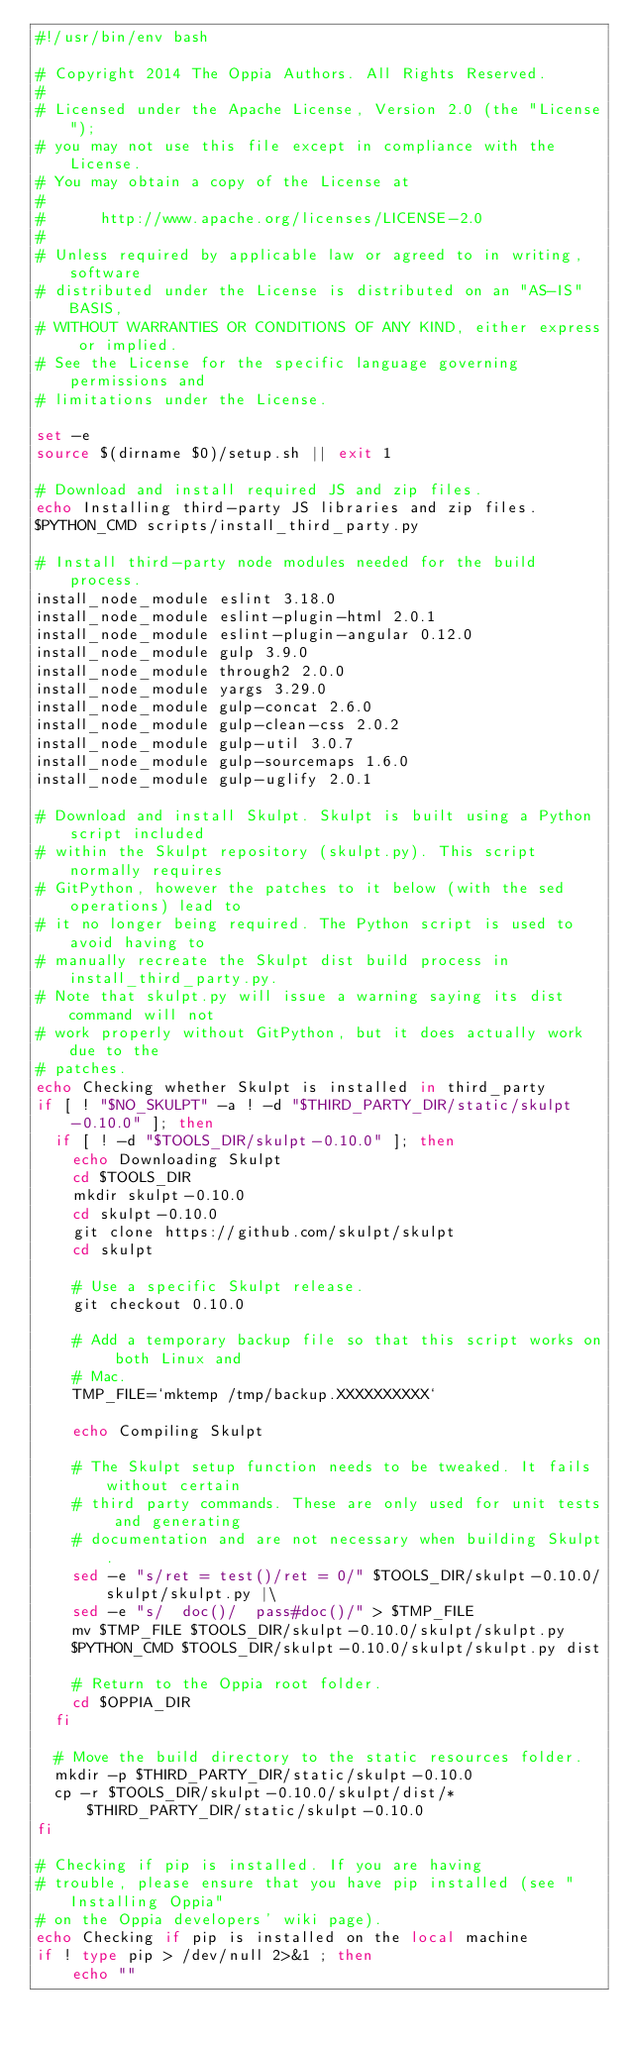<code> <loc_0><loc_0><loc_500><loc_500><_Bash_>#!/usr/bin/env bash

# Copyright 2014 The Oppia Authors. All Rights Reserved.
#
# Licensed under the Apache License, Version 2.0 (the "License");
# you may not use this file except in compliance with the License.
# You may obtain a copy of the License at
#
#      http://www.apache.org/licenses/LICENSE-2.0
#
# Unless required by applicable law or agreed to in writing, software
# distributed under the License is distributed on an "AS-IS" BASIS,
# WITHOUT WARRANTIES OR CONDITIONS OF ANY KIND, either express or implied.
# See the License for the specific language governing permissions and
# limitations under the License.

set -e
source $(dirname $0)/setup.sh || exit 1

# Download and install required JS and zip files.
echo Installing third-party JS libraries and zip files.
$PYTHON_CMD scripts/install_third_party.py

# Install third-party node modules needed for the build process.
install_node_module eslint 3.18.0
install_node_module eslint-plugin-html 2.0.1
install_node_module eslint-plugin-angular 0.12.0
install_node_module gulp 3.9.0
install_node_module through2 2.0.0
install_node_module yargs 3.29.0
install_node_module gulp-concat 2.6.0
install_node_module gulp-clean-css 2.0.2
install_node_module gulp-util 3.0.7
install_node_module gulp-sourcemaps 1.6.0
install_node_module gulp-uglify 2.0.1

# Download and install Skulpt. Skulpt is built using a Python script included
# within the Skulpt repository (skulpt.py). This script normally requires
# GitPython, however the patches to it below (with the sed operations) lead to
# it no longer being required. The Python script is used to avoid having to
# manually recreate the Skulpt dist build process in install_third_party.py.
# Note that skulpt.py will issue a warning saying its dist command will not
# work properly without GitPython, but it does actually work due to the
# patches.
echo Checking whether Skulpt is installed in third_party
if [ ! "$NO_SKULPT" -a ! -d "$THIRD_PARTY_DIR/static/skulpt-0.10.0" ]; then
  if [ ! -d "$TOOLS_DIR/skulpt-0.10.0" ]; then
    echo Downloading Skulpt
    cd $TOOLS_DIR
    mkdir skulpt-0.10.0
    cd skulpt-0.10.0
    git clone https://github.com/skulpt/skulpt
    cd skulpt

    # Use a specific Skulpt release.
    git checkout 0.10.0

    # Add a temporary backup file so that this script works on both Linux and
    # Mac.
    TMP_FILE=`mktemp /tmp/backup.XXXXXXXXXX`

    echo Compiling Skulpt

    # The Skulpt setup function needs to be tweaked. It fails without certain
    # third party commands. These are only used for unit tests and generating
    # documentation and are not necessary when building Skulpt.
    sed -e "s/ret = test()/ret = 0/" $TOOLS_DIR/skulpt-0.10.0/skulpt/skulpt.py |\
    sed -e "s/  doc()/  pass#doc()/" > $TMP_FILE
    mv $TMP_FILE $TOOLS_DIR/skulpt-0.10.0/skulpt/skulpt.py
    $PYTHON_CMD $TOOLS_DIR/skulpt-0.10.0/skulpt/skulpt.py dist

    # Return to the Oppia root folder.
    cd $OPPIA_DIR
  fi

  # Move the build directory to the static resources folder.
  mkdir -p $THIRD_PARTY_DIR/static/skulpt-0.10.0
  cp -r $TOOLS_DIR/skulpt-0.10.0/skulpt/dist/* $THIRD_PARTY_DIR/static/skulpt-0.10.0
fi

# Checking if pip is installed. If you are having
# trouble, please ensure that you have pip installed (see "Installing Oppia"
# on the Oppia developers' wiki page).
echo Checking if pip is installed on the local machine
if ! type pip > /dev/null 2>&1 ; then
    echo ""</code> 